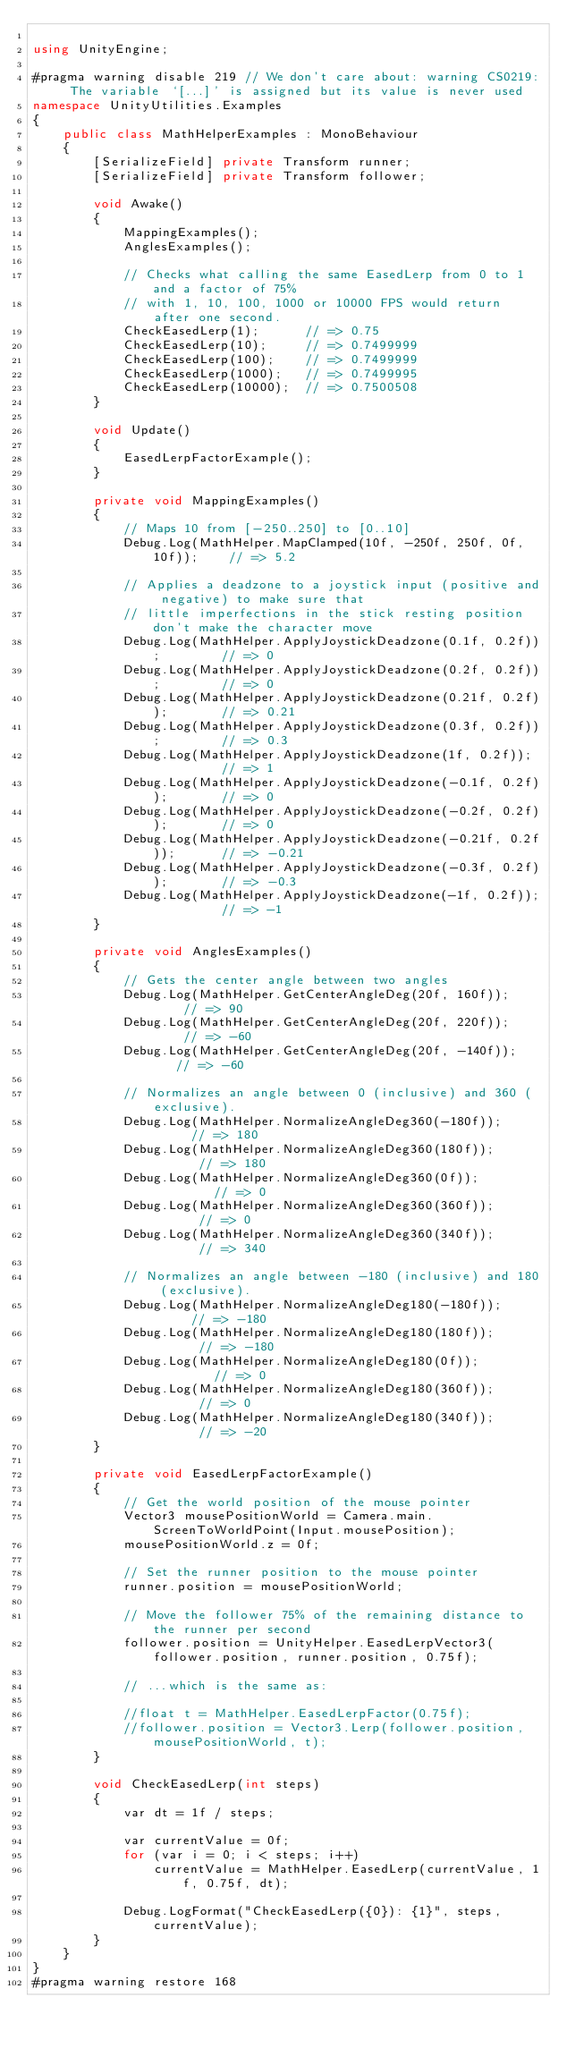<code> <loc_0><loc_0><loc_500><loc_500><_C#_>
using UnityEngine;

#pragma warning disable 219 // We don't care about: warning CS0219: The variable `[...]' is assigned but its value is never used
namespace UnityUtilities.Examples
{
    public class MathHelperExamples : MonoBehaviour
    {
        [SerializeField] private Transform runner;
        [SerializeField] private Transform follower;

        void Awake()
        {
            MappingExamples();
            AnglesExamples();

            // Checks what calling the same EasedLerp from 0 to 1 and a factor of 75%
            // with 1, 10, 100, 1000 or 10000 FPS would return after one second.
            CheckEasedLerp(1);      // => 0.75
            CheckEasedLerp(10);     // => 0.7499999
            CheckEasedLerp(100);    // => 0.7499999
            CheckEasedLerp(1000);   // => 0.7499995
            CheckEasedLerp(10000);  // => 0.7500508
        }

        void Update()
        {
            EasedLerpFactorExample();
        }

        private void MappingExamples()
        {
            // Maps 10 from [-250..250] to [0..10]
            Debug.Log(MathHelper.MapClamped(10f, -250f, 250f, 0f, 10f));    // => 5.2

            // Applies a deadzone to a joystick input (positive and negative) to make sure that
            // little imperfections in the stick resting position don't make the character move
            Debug.Log(MathHelper.ApplyJoystickDeadzone(0.1f, 0.2f));        // => 0
            Debug.Log(MathHelper.ApplyJoystickDeadzone(0.2f, 0.2f));        // => 0
            Debug.Log(MathHelper.ApplyJoystickDeadzone(0.21f, 0.2f));       // => 0.21
            Debug.Log(MathHelper.ApplyJoystickDeadzone(0.3f, 0.2f));        // => 0.3
            Debug.Log(MathHelper.ApplyJoystickDeadzone(1f, 0.2f));          // => 1
            Debug.Log(MathHelper.ApplyJoystickDeadzone(-0.1f, 0.2f));       // => 0
            Debug.Log(MathHelper.ApplyJoystickDeadzone(-0.2f, 0.2f));       // => 0
            Debug.Log(MathHelper.ApplyJoystickDeadzone(-0.21f, 0.2f));      // => -0.21
            Debug.Log(MathHelper.ApplyJoystickDeadzone(-0.3f, 0.2f));       // => -0.3
            Debug.Log(MathHelper.ApplyJoystickDeadzone(-1f, 0.2f));         // => -1
        }

        private void AnglesExamples()
        {
            // Gets the center angle between two angles
            Debug.Log(MathHelper.GetCenterAngleDeg(20f, 160f));     // => 90
            Debug.Log(MathHelper.GetCenterAngleDeg(20f, 220f));     // => -60
            Debug.Log(MathHelper.GetCenterAngleDeg(20f, -140f));    // => -60

            // Normalizes an angle between 0 (inclusive) and 360 (exclusive).
            Debug.Log(MathHelper.NormalizeAngleDeg360(-180f));      // => 180
            Debug.Log(MathHelper.NormalizeAngleDeg360(180f));       // => 180
            Debug.Log(MathHelper.NormalizeAngleDeg360(0f));         // => 0
            Debug.Log(MathHelper.NormalizeAngleDeg360(360f));       // => 0
            Debug.Log(MathHelper.NormalizeAngleDeg360(340f));       // => 340

            // Normalizes an angle between -180 (inclusive) and 180 (exclusive).
            Debug.Log(MathHelper.NormalizeAngleDeg180(-180f));      // => -180
            Debug.Log(MathHelper.NormalizeAngleDeg180(180f));       // => -180
            Debug.Log(MathHelper.NormalizeAngleDeg180(0f));         // => 0
            Debug.Log(MathHelper.NormalizeAngleDeg180(360f));       // => 0
            Debug.Log(MathHelper.NormalizeAngleDeg180(340f));       // => -20
        }

        private void EasedLerpFactorExample()
        {
            // Get the world position of the mouse pointer
            Vector3 mousePositionWorld = Camera.main.ScreenToWorldPoint(Input.mousePosition);
            mousePositionWorld.z = 0f;

            // Set the runner position to the mouse pointer
            runner.position = mousePositionWorld;

            // Move the follower 75% of the remaining distance to the runner per second
            follower.position = UnityHelper.EasedLerpVector3(follower.position, runner.position, 0.75f);

            // ...which is the same as:

            //float t = MathHelper.EasedLerpFactor(0.75f);
            //follower.position = Vector3.Lerp(follower.position, mousePositionWorld, t);
        }

        void CheckEasedLerp(int steps)
        {
            var dt = 1f / steps;

            var currentValue = 0f;
            for (var i = 0; i < steps; i++)
                currentValue = MathHelper.EasedLerp(currentValue, 1f, 0.75f, dt);

            Debug.LogFormat("CheckEasedLerp({0}): {1}", steps, currentValue);
        }
    }
}
#pragma warning restore 168
                           
                           </code> 